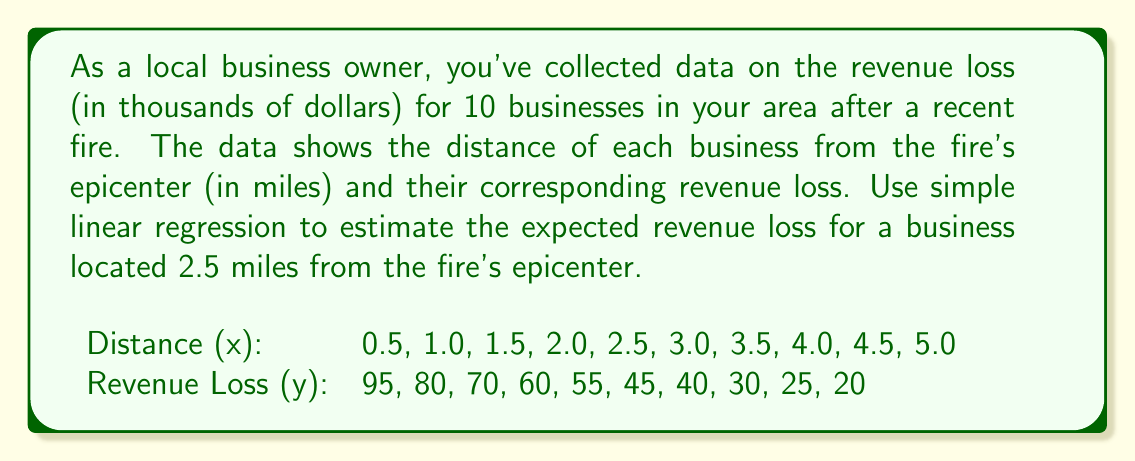Solve this math problem. To solve this problem, we'll use simple linear regression. The steps are as follows:

1. Calculate the means of x and y:
   $\bar{x} = \frac{\sum x}{n} = \frac{27.5}{10} = 2.75$
   $\bar{y} = \frac{\sum y}{n} = \frac{520}{10} = 52$

2. Calculate $\sum (x - \bar{x})(y - \bar{y})$ and $\sum (x - \bar{x})^2$:
   $\sum (x - \bar{x})(y - \bar{y}) = -168.75$
   $\sum (x - \bar{x})^2 = 13.75$

3. Calculate the slope (b) of the regression line:
   $b = \frac{\sum (x - \bar{x})(y - \bar{y})}{\sum (x - \bar{x})^2} = \frac{-168.75}{13.75} = -12.27$

4. Calculate the y-intercept (a) of the regression line:
   $a = \bar{y} - b\bar{x} = 52 - (-12.27 \times 2.75) = 85.74$

5. The regression equation is:
   $y = 85.74 - 12.27x$

6. To estimate the revenue loss for a business 2.5 miles from the epicenter, substitute x = 2.5:
   $y = 85.74 - 12.27(2.5) = 85.74 - 30.68 = 55.06$

Therefore, the estimated revenue loss for a business 2.5 miles from the fire's epicenter is approximately $55,060.
Answer: $55,060 